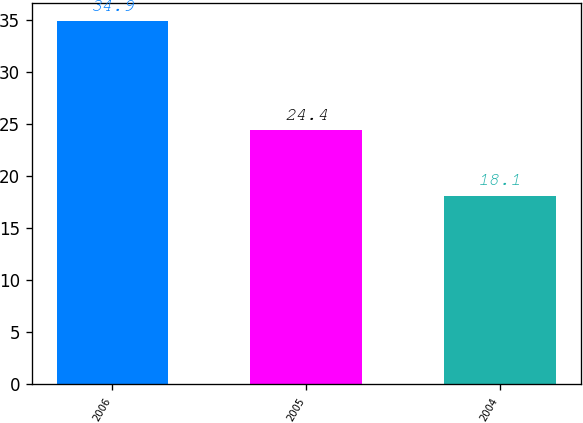<chart> <loc_0><loc_0><loc_500><loc_500><bar_chart><fcel>2006<fcel>2005<fcel>2004<nl><fcel>34.9<fcel>24.4<fcel>18.1<nl></chart> 